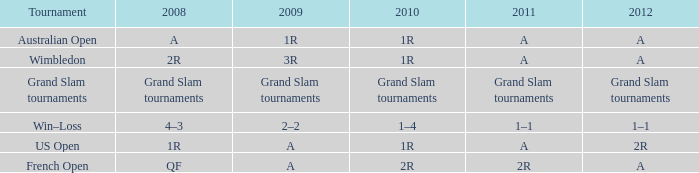Name the 2009 ffor 2010 of 1r and 2012 of a and 2008 of 2r 3R. 